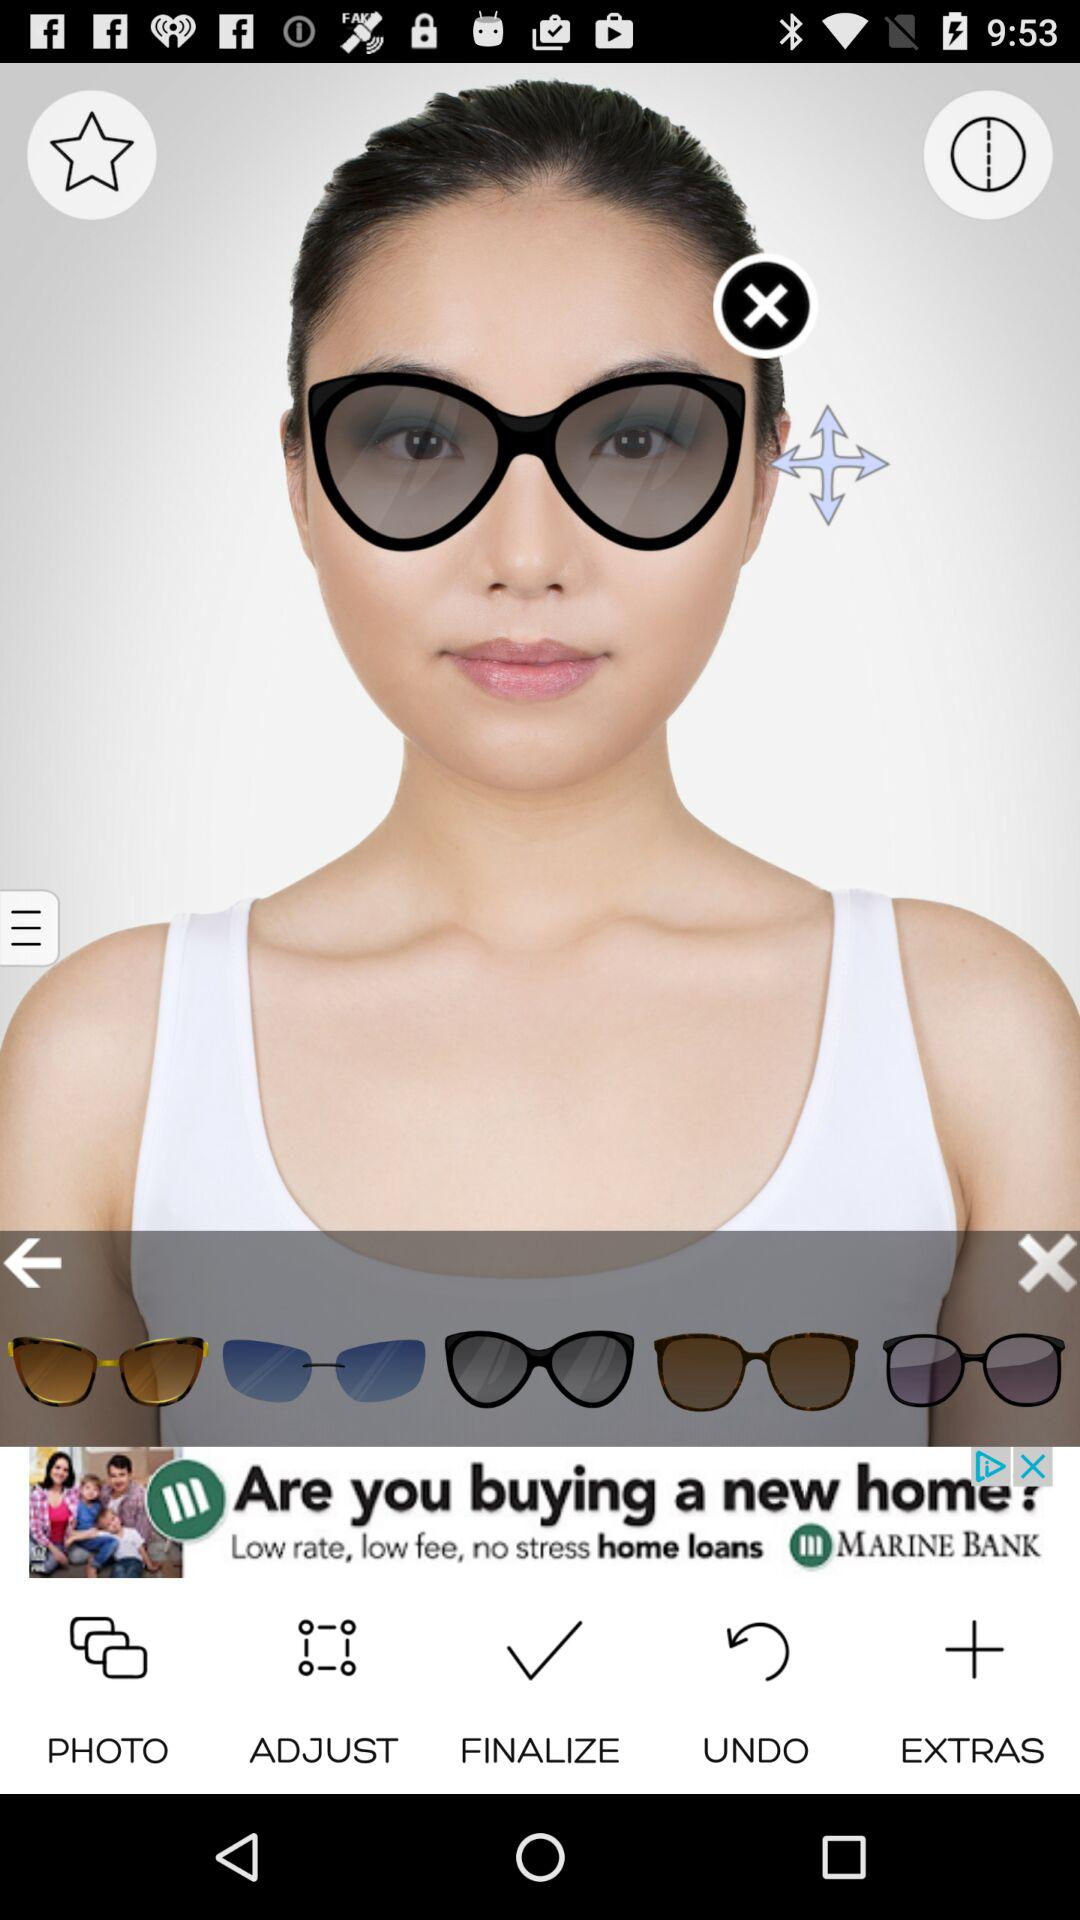How many sunglasses are there in total?
Answer the question using a single word or phrase. 5 